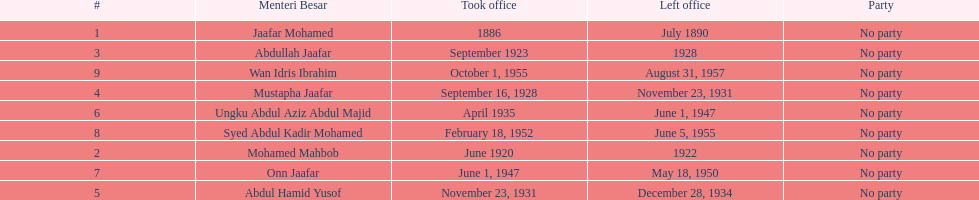Other than abullah jaafar, name someone with the same last name. Mustapha Jaafar. Would you mind parsing the complete table? {'header': ['#', 'Menteri Besar', 'Took office', 'Left office', 'Party'], 'rows': [['1', 'Jaafar Mohamed', '1886', 'July 1890', 'No party'], ['3', 'Abdullah Jaafar', 'September 1923', '1928', 'No party'], ['9', 'Wan Idris Ibrahim', 'October 1, 1955', 'August 31, 1957', 'No party'], ['4', 'Mustapha Jaafar', 'September 16, 1928', 'November 23, 1931', 'No party'], ['6', 'Ungku Abdul Aziz Abdul Majid', 'April 1935', 'June 1, 1947', 'No party'], ['8', 'Syed Abdul Kadir Mohamed', 'February 18, 1952', 'June 5, 1955', 'No party'], ['2', 'Mohamed Mahbob', 'June 1920', '1922', 'No party'], ['7', 'Onn Jaafar', 'June 1, 1947', 'May 18, 1950', 'No party'], ['5', 'Abdul Hamid Yusof', 'November 23, 1931', 'December 28, 1934', 'No party']]} 